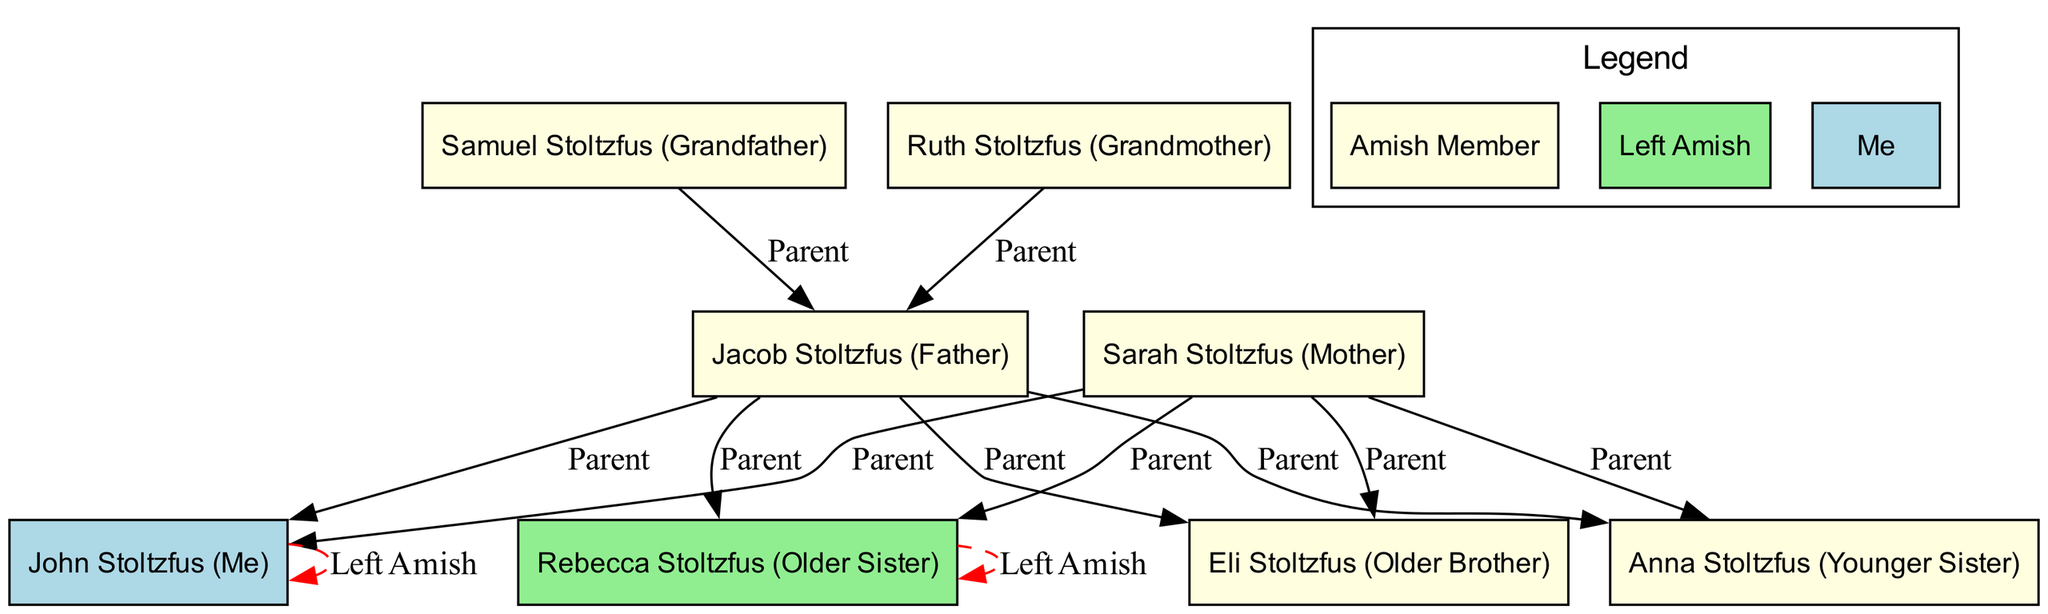What is the total number of nodes in the diagram? The diagram has 8 nodes representing family members. Each node corresponds to a unique individual in the family tree. To find the number of nodes, you can simply count them in the provided data.
Answer: 8 Who are the parents of Jacob Stoltzfus? Jacob Stoltzfus has two parents listed in the diagram: Samuel Stoltzfus and Ruth Stoltzfus. They each have a directed edge labeled "Parent" pointing to Jacob, indicating their parental relationship.
Answer: Samuel Stoltzfus, Ruth Stoltzfus Which sibling is identified as "Me"? The node labeled "Me" points to John Stoltzfus, which corresponds with the identification in the data. It is indicated by the unique ID assigned to him in the diagram.
Answer: John Stoltzfus How many family members have left the Amish community? In the diagram, John Stoltzfus and Rebecca Stoltzfus are marked as having left the Amish community. This is shown by the red dashed edges that indicate "Left Amish." Counting these nodes shows there are 2 of them.
Answer: 2 What color represents someone who has left the Amish community? The color used for nodes that represent individuals who have left the Amish community is light green. This color is assigned to display individuals who are no longer part of that community.
Answer: Light green Which sibling has an edge indicating "Left Amish"? The edge labeled "Left Amish" is directed toward John Stoltzfus and Rebecca Stoltzfus. Since both siblings share this characteristic as indicated by the edges, either could be considered as the answer.
Answer: John Stoltzfus, Rebecca Stoltzfus What type of relationship is shown between the grandparents and Jacob Stoltzfus? The relationship between Samuel Stoltzfus, Ruth Stoltzfus, and Jacob Stoltzfus is "Parent". Two edges labeled "Parent" indicate that both grandparents are the parents of Jacob.
Answer: Parent How many edges are presented in the diagram? The diagram has a total of 11 edges. These edges represent familial relationships, as well as the instances of individuals leaving the Amish community. You can count each relationship listed in the edges section of the data.
Answer: 11 